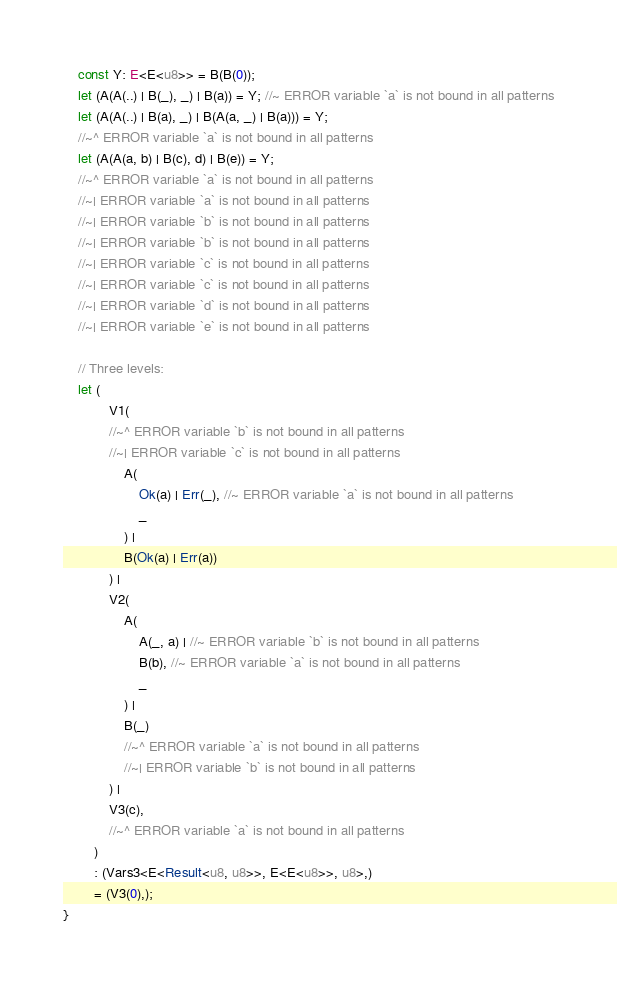Convert code to text. <code><loc_0><loc_0><loc_500><loc_500><_Rust_>    const Y: E<E<u8>> = B(B(0));
    let (A(A(..) | B(_), _) | B(a)) = Y; //~ ERROR variable `a` is not bound in all patterns
    let (A(A(..) | B(a), _) | B(A(a, _) | B(a))) = Y;
    //~^ ERROR variable `a` is not bound in all patterns
    let (A(A(a, b) | B(c), d) | B(e)) = Y;
    //~^ ERROR variable `a` is not bound in all patterns
    //~| ERROR variable `a` is not bound in all patterns
    //~| ERROR variable `b` is not bound in all patterns
    //~| ERROR variable `b` is not bound in all patterns
    //~| ERROR variable `c` is not bound in all patterns
    //~| ERROR variable `c` is not bound in all patterns
    //~| ERROR variable `d` is not bound in all patterns
    //~| ERROR variable `e` is not bound in all patterns

    // Three levels:
    let (
            V1(
            //~^ ERROR variable `b` is not bound in all patterns
            //~| ERROR variable `c` is not bound in all patterns
                A(
                    Ok(a) | Err(_), //~ ERROR variable `a` is not bound in all patterns
                    _
                ) |
                B(Ok(a) | Err(a))
            ) |
            V2(
                A(
                    A(_, a) | //~ ERROR variable `b` is not bound in all patterns
                    B(b), //~ ERROR variable `a` is not bound in all patterns
                    _
                ) |
                B(_)
                //~^ ERROR variable `a` is not bound in all patterns
                //~| ERROR variable `b` is not bound in all patterns
            ) |
            V3(c),
            //~^ ERROR variable `a` is not bound in all patterns
        )
        : (Vars3<E<Result<u8, u8>>, E<E<u8>>, u8>,)
        = (V3(0),);
}
</code> 